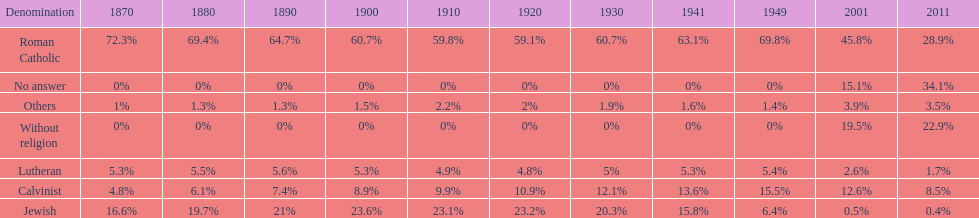How many denominations never dropped below 20%? 1. 